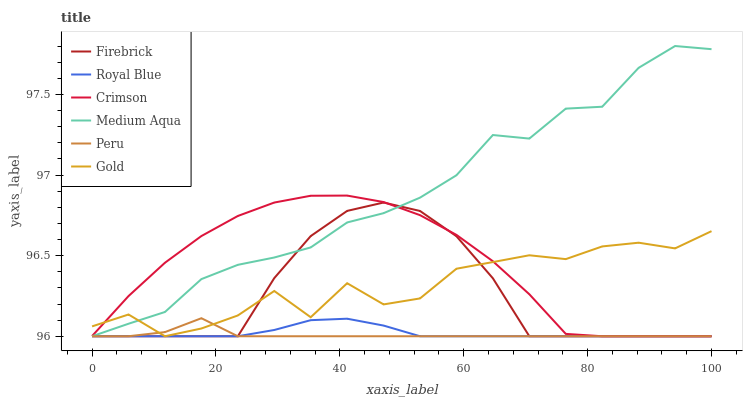Does Peru have the minimum area under the curve?
Answer yes or no. Yes. Does Medium Aqua have the maximum area under the curve?
Answer yes or no. Yes. Does Firebrick have the minimum area under the curve?
Answer yes or no. No. Does Firebrick have the maximum area under the curve?
Answer yes or no. No. Is Royal Blue the smoothest?
Answer yes or no. Yes. Is Gold the roughest?
Answer yes or no. Yes. Is Firebrick the smoothest?
Answer yes or no. No. Is Firebrick the roughest?
Answer yes or no. No. Does Gold have the lowest value?
Answer yes or no. Yes. Does Medium Aqua have the highest value?
Answer yes or no. Yes. Does Firebrick have the highest value?
Answer yes or no. No. Does Peru intersect Medium Aqua?
Answer yes or no. Yes. Is Peru less than Medium Aqua?
Answer yes or no. No. Is Peru greater than Medium Aqua?
Answer yes or no. No. 